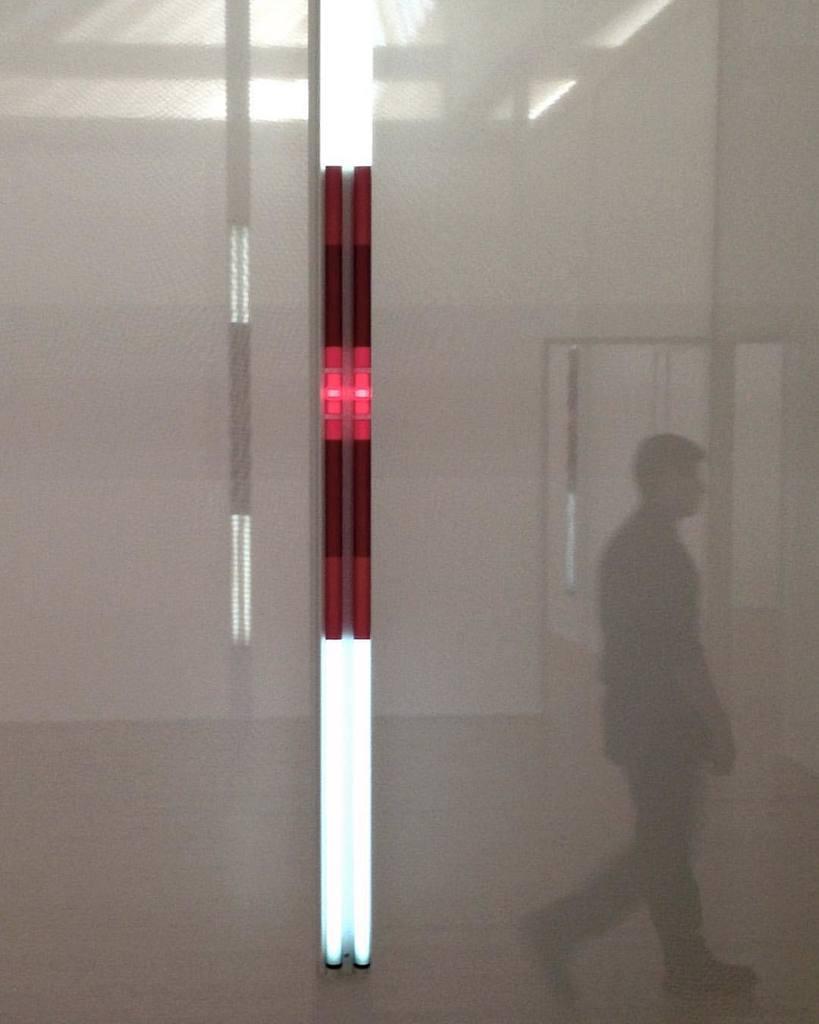In one or two sentences, can you explain what this image depicts? In this image in the center there is a light. On the right side there is a person walking. In the background there is a light and there is a door. 